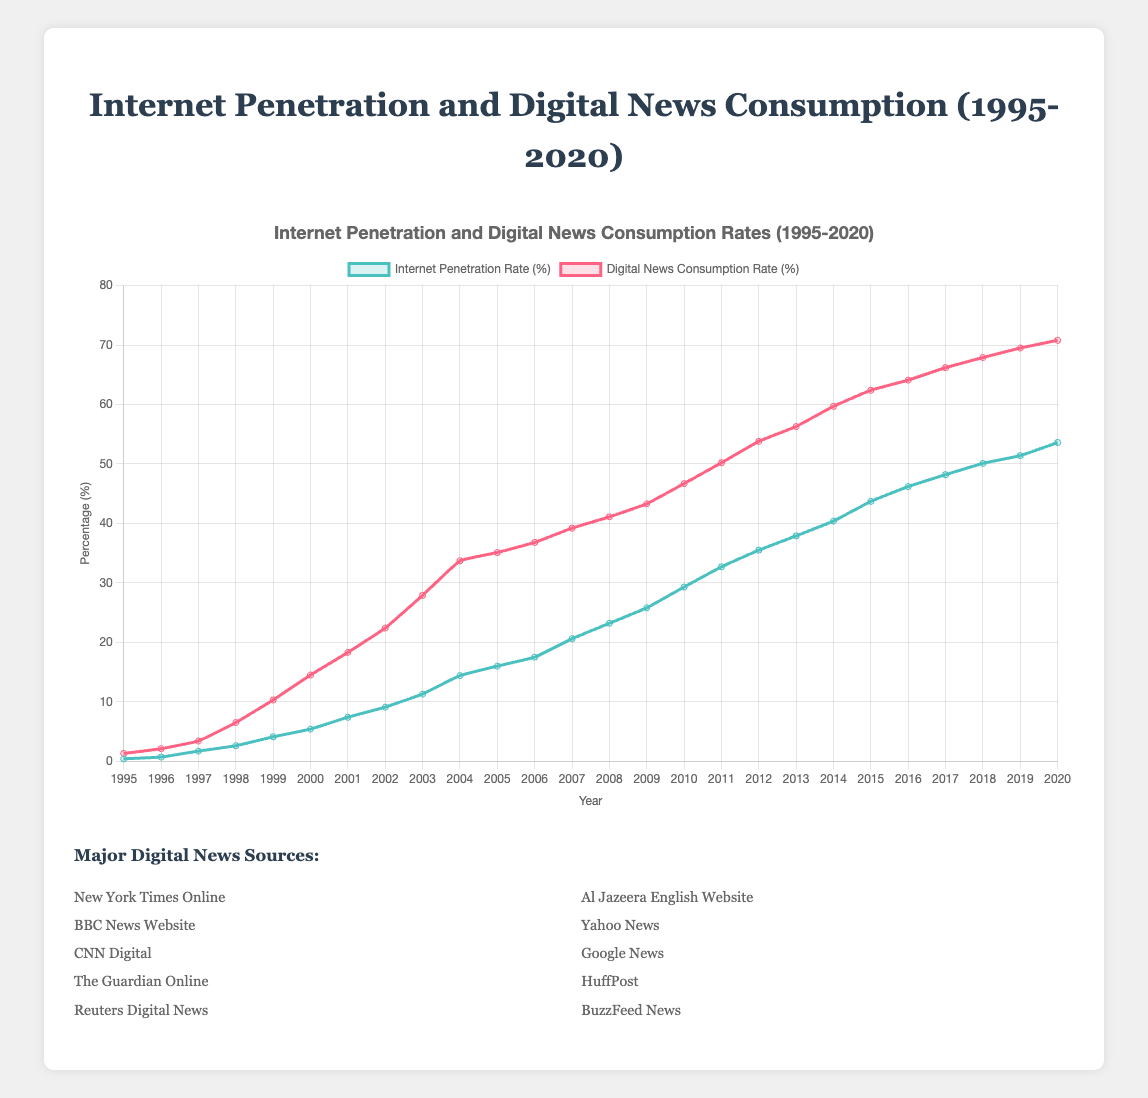What was the Internet penetration rate in 2000? Locate the blue line in the figure and find the data point for the year 2000. The Internet penetration rate in 2000 is between 5% and 6%.
Answer: 5.4% How much did the digital news consumption rate increase from 1995 to 2000? Find the red line data points for the years 1995 and 2000. Subtract the 1995 value from the 2000 value: 14.5% - 1.3% = 13.2%.
Answer: 13.2% Which year had the greatest increase in Internet penetration rate? Compare the year-to-year increases by examining the slopes of the blue line. The steepest slope appears around 2014-2015.
Answer: 2014-2015 In which year did the digital news consumption rate surpass 40%? Identify the red line data point that first crosses the 40% threshold. This occurs between 2008 and 2009.
Answer: 2008 How do the Internet penetration and digital news consumption rates compare in 2015? Locate the data points for both rates in the year 2015. The Internet penetration rate is around 43.7%, while digital news consumption is around 62.4%.
Answer: The digital news consumption rate is higher What was the difference between Internet penetration and digital news consumption rates in 2010? Find the data points for both rates in 2010 and subtract the Internet penetration rate from the digital news consumption rate: 46.7% - 29.3% = 17.4%.
Answer: 17.4% By what percentage did the Internet penetration rate grow from 1995 to 2020? Find the initial and final values of the Internet penetration rate and calculate the percentage increase: ((53.6 - 0.4) / 0.4) * 100 = 13,300%.
Answer: 13,300% In what year was the digital news consumption rate twice the Internet penetration rate? Compare the data points where the red line is approximately twice the value of the blue line, which seems to be around 2004.
Answer: 2004 Does the Internet penetration rate ever surpass the digital news consumption rate? Examine the entire graph to see if the blue line ever exceeds the red line. It does not at any point.
Answer: No What was the compounded increase in the digital news consumption rate from 2009 to 2015? Find the values for 2009 and 2015, then calculate the compounded increase: ((62.4 - 39.2) / 39.2) * 100 = 59.18%.
Answer: 59.18% Which line shows a more consistent upward trend over the years, and why? Examine the slopes of both lines over the years. The blue line (Internet penetration rate) shows a steadier increasing slope, while the red line (digital news consumption rate) has more variability in slopes.
Answer: Internet penetration rate 